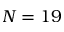Convert formula to latex. <formula><loc_0><loc_0><loc_500><loc_500>N = 1 9</formula> 